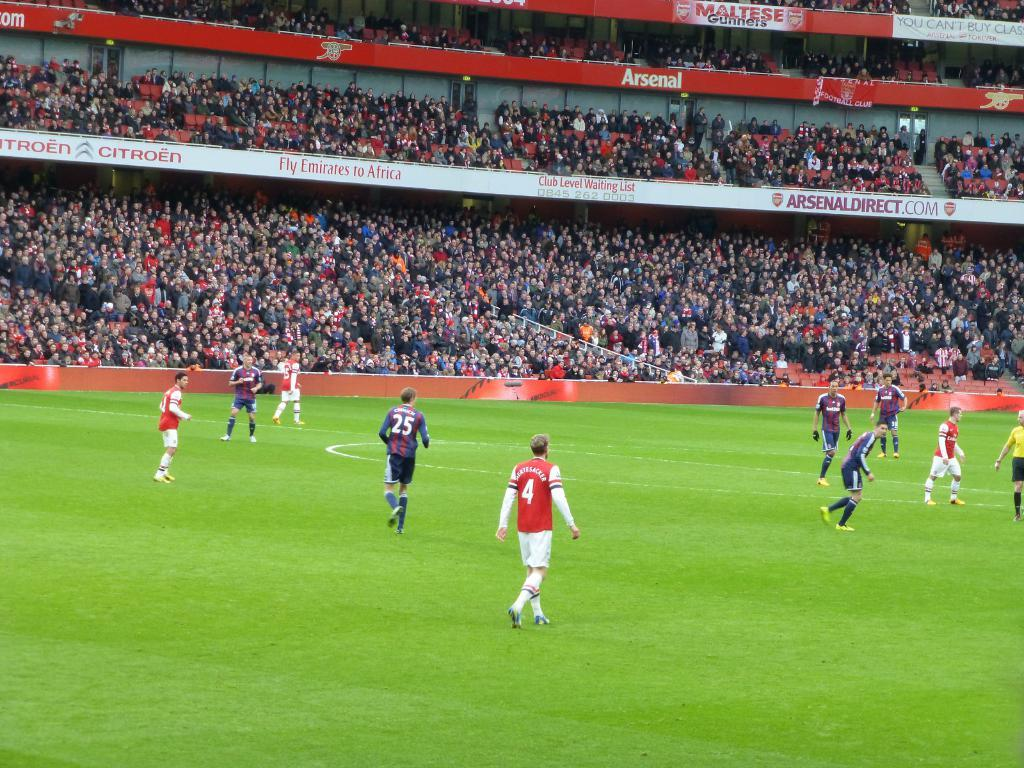What is happening on the ground in the image? There are people on the ground in the image. What can be seen in the background of the image? There are advertisement boards and people visible in the background of the image. Where is the dock located in the image? There is no dock present in the image. How many ladybugs can be seen on the people in the image? There are no ladybugs visible in the image. 